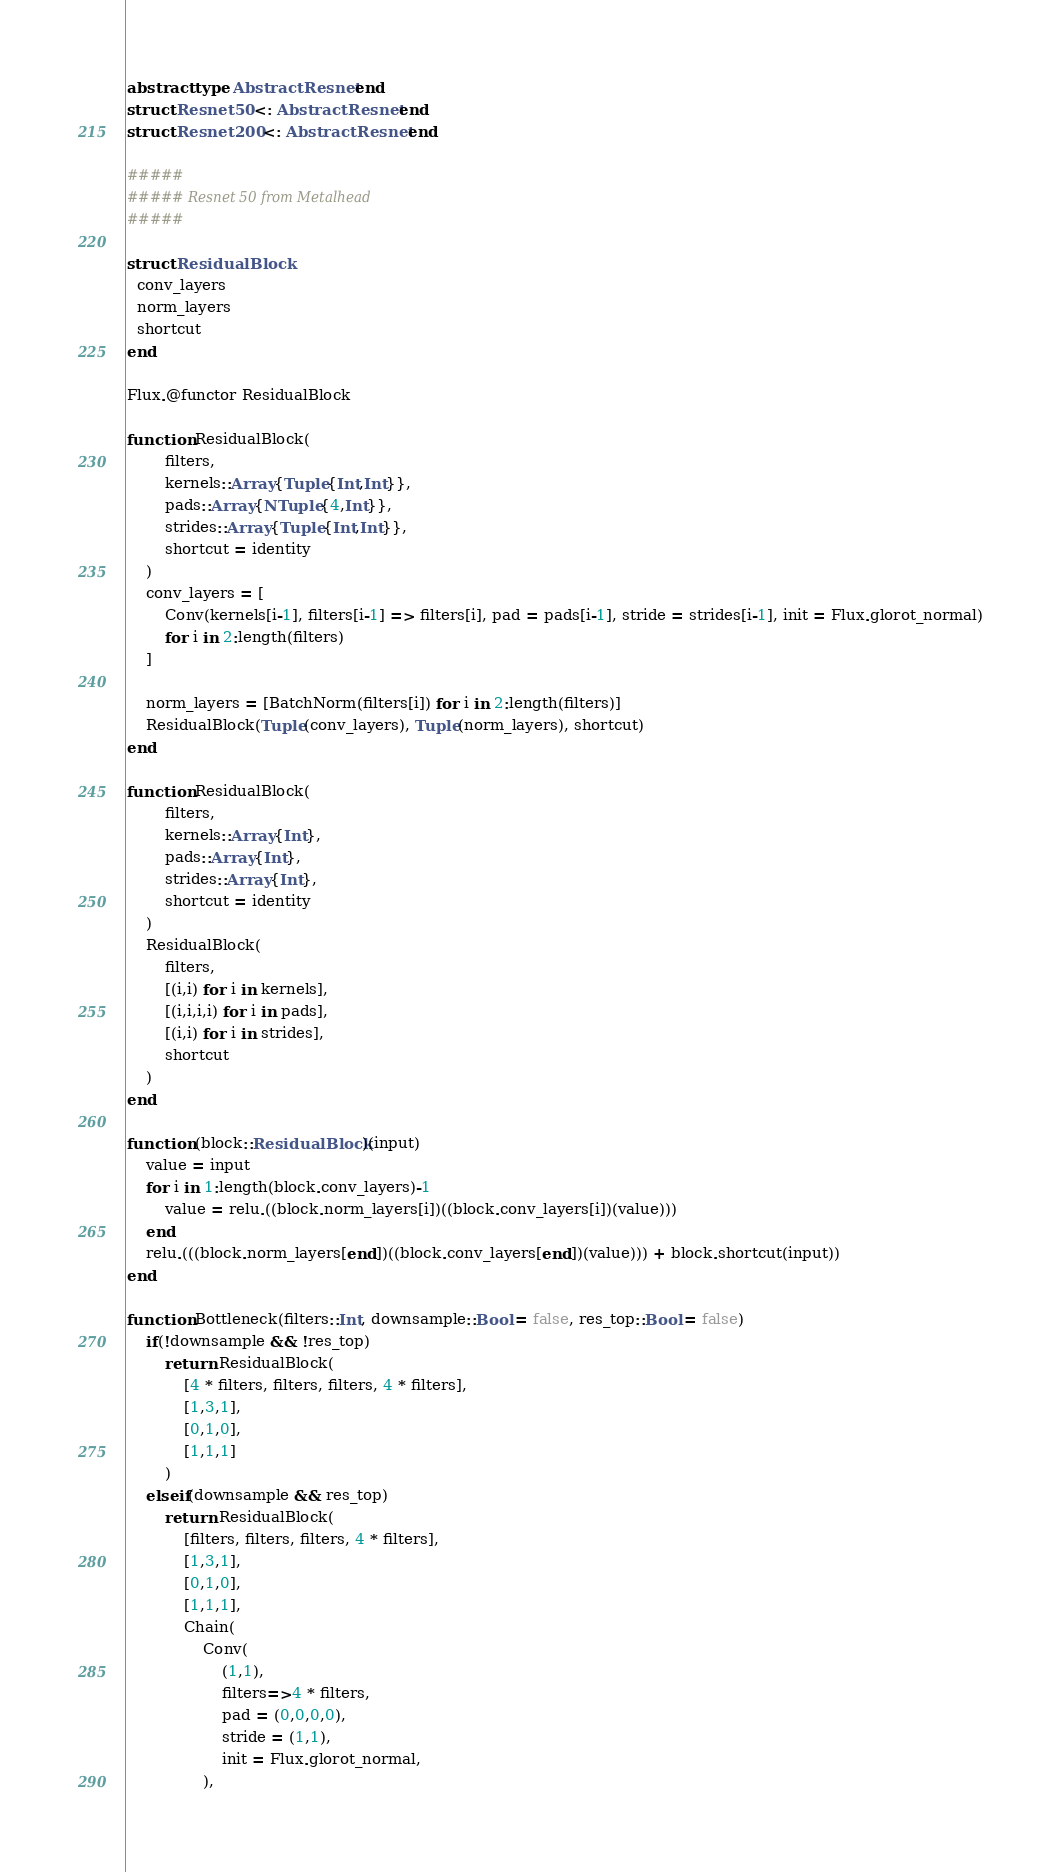Convert code to text. <code><loc_0><loc_0><loc_500><loc_500><_Julia_>abstract type AbstractResnet end
struct Resnet50 <: AbstractResnet end
struct Resnet200 <: AbstractResnet end

#####
##### Resnet 50 from Metalhead
#####

struct ResidualBlock
  conv_layers
  norm_layers
  shortcut
end

Flux.@functor ResidualBlock

function ResidualBlock(
        filters,
        kernels::Array{Tuple{Int,Int}},
        pads::Array{NTuple{4,Int}},
        strides::Array{Tuple{Int,Int}},
        shortcut = identity
    )
    conv_layers = [
        Conv(kernels[i-1], filters[i-1] => filters[i], pad = pads[i-1], stride = strides[i-1], init = Flux.glorot_normal)
        for i in 2:length(filters)
    ]

    norm_layers = [BatchNorm(filters[i]) for i in 2:length(filters)]
    ResidualBlock(Tuple(conv_layers), Tuple(norm_layers), shortcut)
end

function ResidualBlock(
        filters,
        kernels::Array{Int},
        pads::Array{Int},
        strides::Array{Int},
        shortcut = identity
    )
    ResidualBlock(
        filters,
        [(i,i) for i in kernels],
        [(i,i,i,i) for i in pads],
        [(i,i) for i in strides],
        shortcut
    )
end

function (block::ResidualBlock)(input)
    value = input
    for i in 1:length(block.conv_layers)-1
        value = relu.((block.norm_layers[i])((block.conv_layers[i])(value)))
    end
    relu.(((block.norm_layers[end])((block.conv_layers[end])(value))) + block.shortcut(input))
end

function Bottleneck(filters::Int, downsample::Bool = false, res_top::Bool = false)
    if(!downsample && !res_top)
        return ResidualBlock(
            [4 * filters, filters, filters, 4 * filters],
            [1,3,1],
            [0,1,0],
            [1,1,1]
        )
    elseif(downsample && res_top)
        return ResidualBlock(
            [filters, filters, filters, 4 * filters],
            [1,3,1],
            [0,1,0],
            [1,1,1],
            Chain(
                Conv(
                    (1,1),
                    filters=>4 * filters,
                    pad = (0,0,0,0),
                    stride = (1,1),
                    init = Flux.glorot_normal,
                ),</code> 